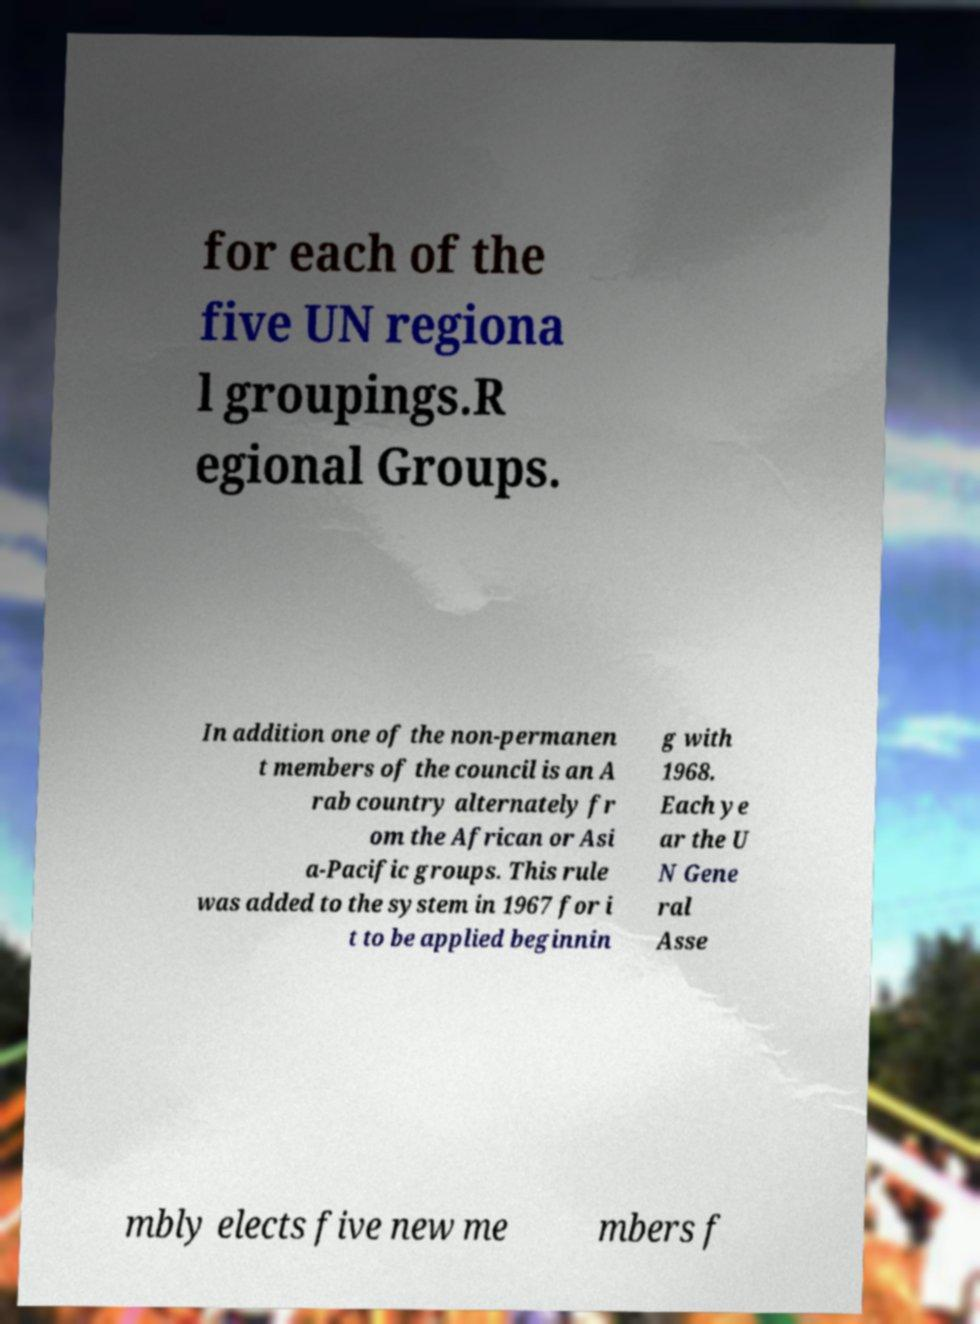What messages or text are displayed in this image? I need them in a readable, typed format. for each of the five UN regiona l groupings.R egional Groups. In addition one of the non-permanen t members of the council is an A rab country alternately fr om the African or Asi a-Pacific groups. This rule was added to the system in 1967 for i t to be applied beginnin g with 1968. Each ye ar the U N Gene ral Asse mbly elects five new me mbers f 